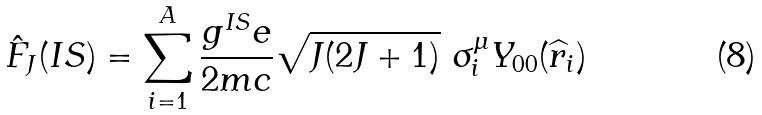<formula> <loc_0><loc_0><loc_500><loc_500>\hat { F } _ { J } ( I S ) = \sum _ { i = 1 } ^ { A } \frac { g ^ { I S } e } { 2 m c } \sqrt { J ( 2 J + 1 ) } \ \sigma _ { i } ^ { \mu } Y _ { 0 0 } ( \widehat { r } _ { i } )</formula> 